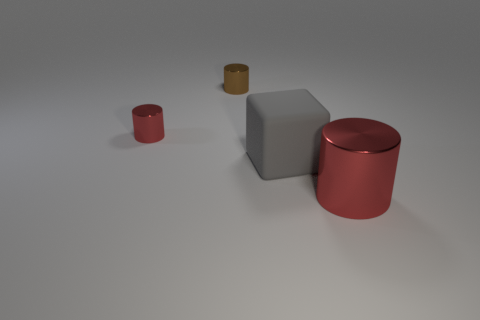Subtract all cyan blocks. How many red cylinders are left? 2 Subtract all red metal cylinders. How many cylinders are left? 1 Add 3 large red metal cylinders. How many objects exist? 7 Subtract all cubes. How many objects are left? 3 Subtract all purple cylinders. Subtract all green cubes. How many cylinders are left? 3 Add 3 red metal things. How many red metal things are left? 5 Add 3 blocks. How many blocks exist? 4 Subtract 0 green blocks. How many objects are left? 4 Subtract all small cyan things. Subtract all metal cylinders. How many objects are left? 1 